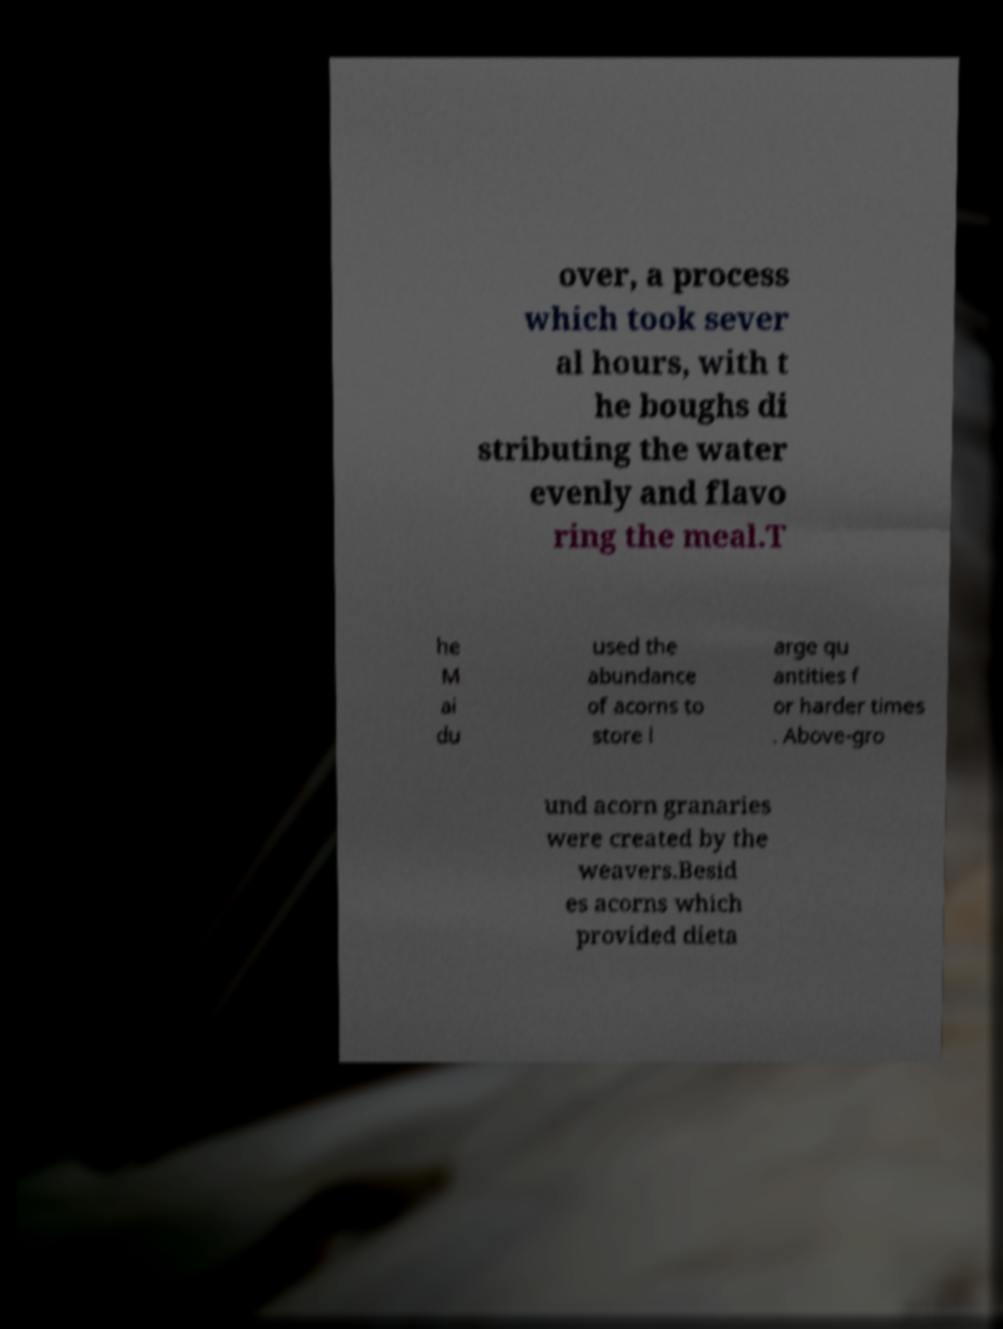Please read and relay the text visible in this image. What does it say? over, a process which took sever al hours, with t he boughs di stributing the water evenly and flavo ring the meal.T he M ai du used the abundance of acorns to store l arge qu antities f or harder times . Above-gro und acorn granaries were created by the weavers.Besid es acorns which provided dieta 